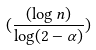Convert formula to latex. <formula><loc_0><loc_0><loc_500><loc_500>( \frac { ( \log n ) } { \log ( 2 - \alpha ) } )</formula> 